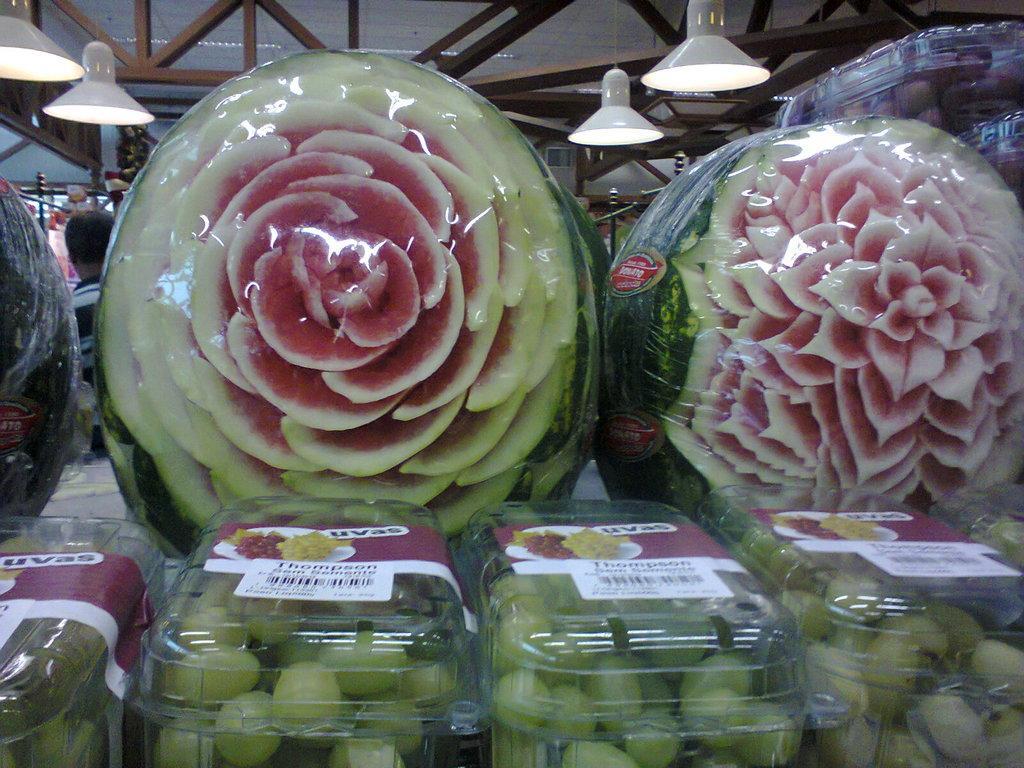Can you describe this image briefly? In this picture, we see the plastic boxes containing the grapes. We see the stickers pasted on the boxes. In the middle, we see the carved watermelons are covered with a plastic cover. Behind that, we see a man is standing. On the right side, we see a plastic box containing the fruits. In the background, we see a wall. At the top, we see the lights and the roof of the building. 